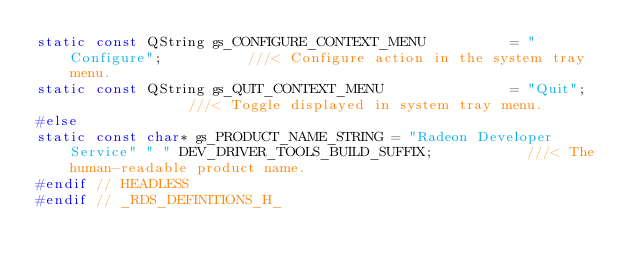<code> <loc_0><loc_0><loc_500><loc_500><_C_>static const QString gs_CONFIGURE_CONTEXT_MENU          = "Configure";          ///< Configure action in the system tray menu.
static const QString gs_QUIT_CONTEXT_MENU               = "Quit";               ///< Toggle displayed in system tray menu.
#else
static const char* gs_PRODUCT_NAME_STRING = "Radeon Developer Service" " " DEV_DRIVER_TOOLS_BUILD_SUFFIX;           ///< The human-readable product name.
#endif // HEADLESS
#endif // _RDS_DEFINITIONS_H_
</code> 